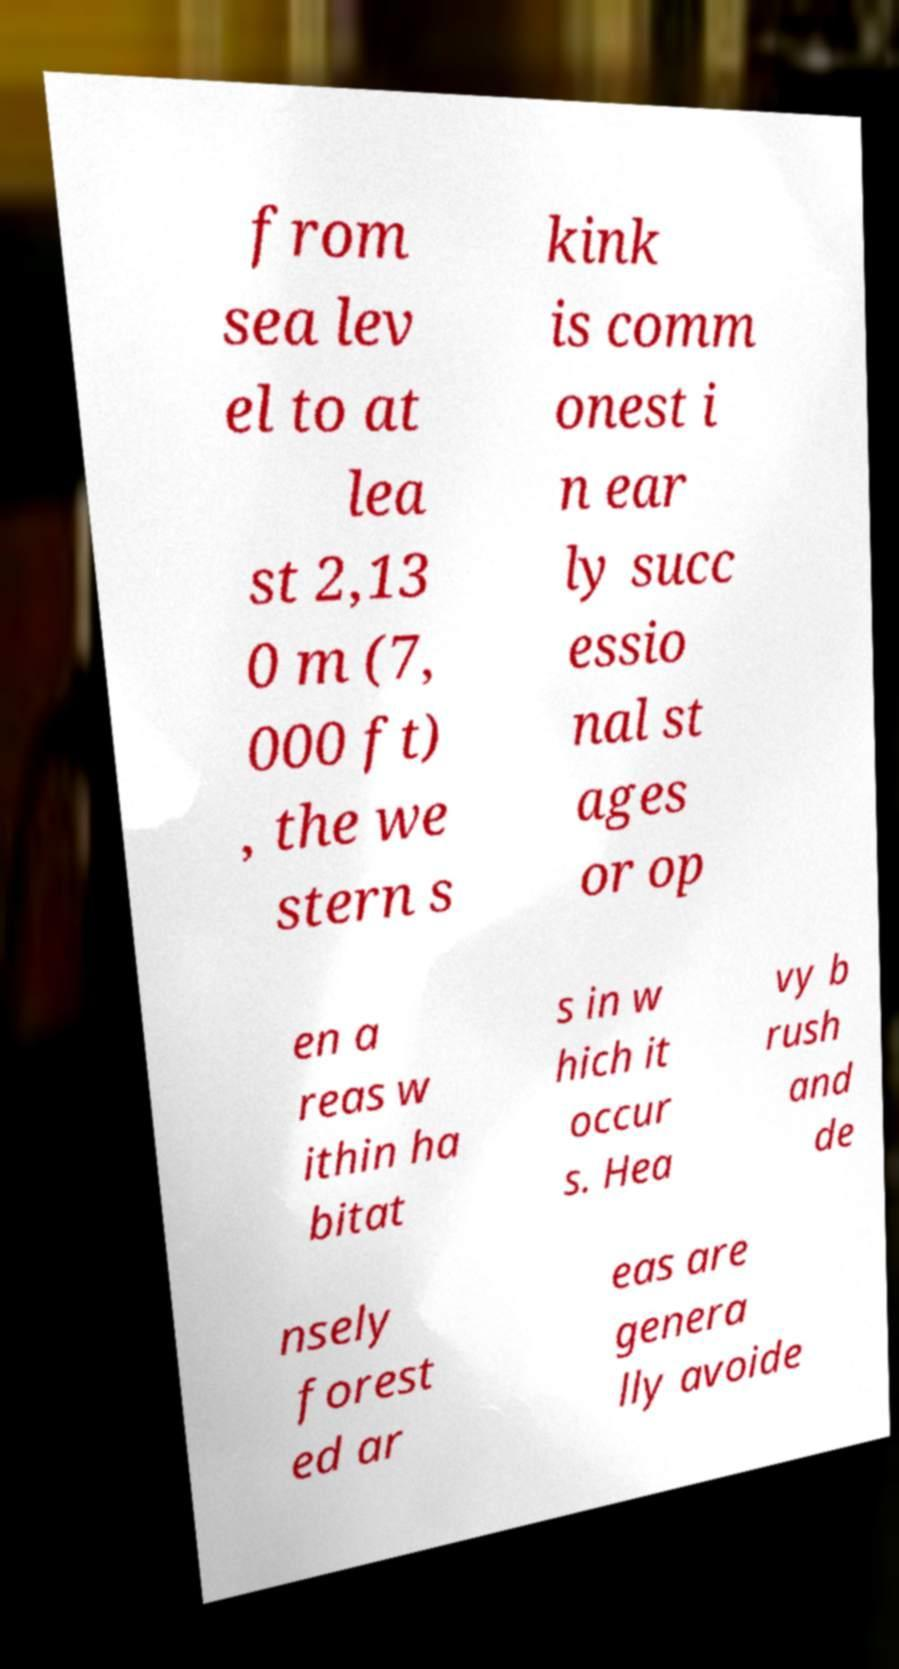For documentation purposes, I need the text within this image transcribed. Could you provide that? from sea lev el to at lea st 2,13 0 m (7, 000 ft) , the we stern s kink is comm onest i n ear ly succ essio nal st ages or op en a reas w ithin ha bitat s in w hich it occur s. Hea vy b rush and de nsely forest ed ar eas are genera lly avoide 